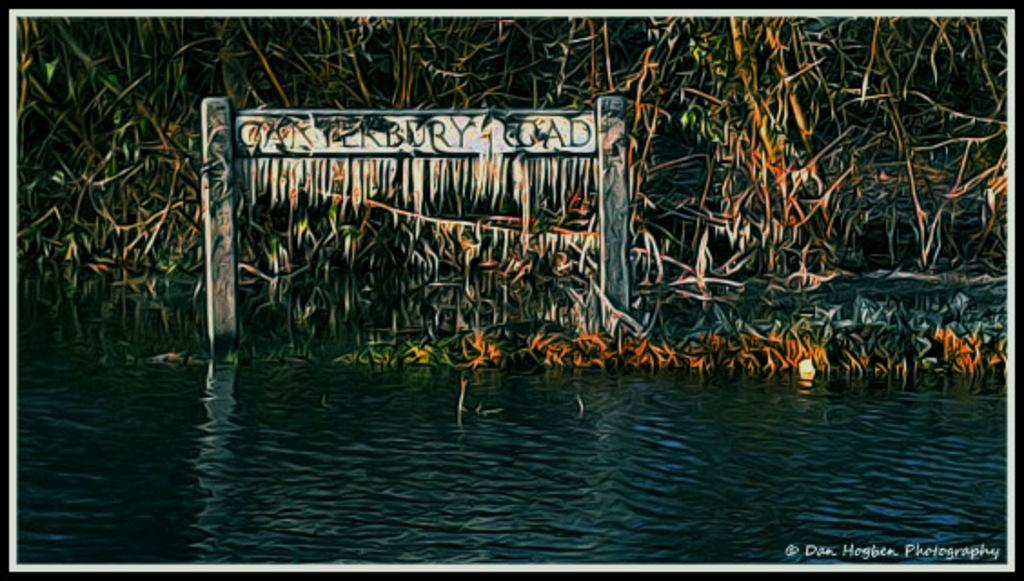What type of editing has been done to the image? The image is edited, but the specific type of editing is not mentioned in the facts. What can be seen in the image besides the editing? There is water visible in the image, along with trees, a name board, and a watermark on the right bottom of the picture. Can you describe the watermark in the image? The watermark is located on the right bottom of the picture. What is the purpose of the name board in the image? The purpose of the name board is not mentioned in the facts. What type of shoe is being worn by the person in the image? There is no person present in the image, so it is not possible to determine what type of shoe they might be wearing. 